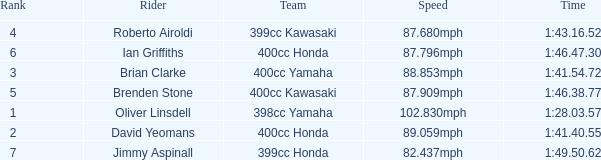What is the rank of the rider with time of 1:41.40.55? 2.0. 